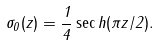Convert formula to latex. <formula><loc_0><loc_0><loc_500><loc_500>\sigma _ { 0 } ( z ) = \frac { 1 } { 4 } \sec h ( \pi z / 2 ) .</formula> 